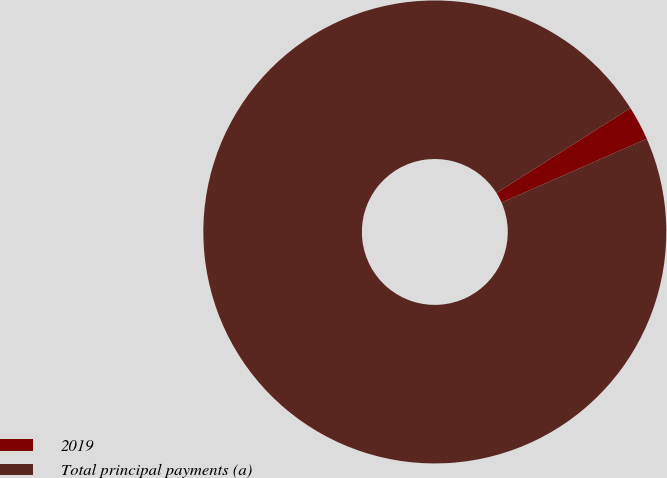Convert chart. <chart><loc_0><loc_0><loc_500><loc_500><pie_chart><fcel>2019<fcel>Total principal payments (a)<nl><fcel>2.39%<fcel>97.61%<nl></chart> 